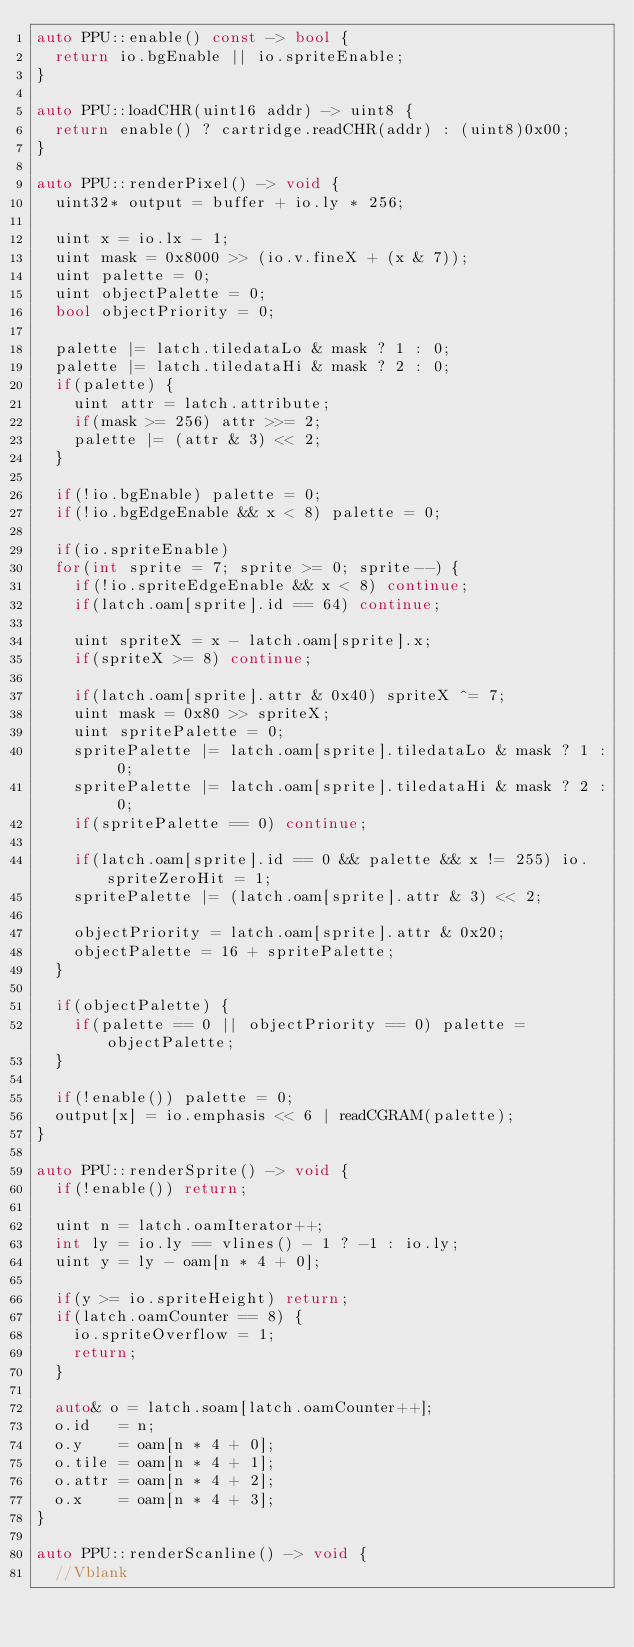Convert code to text. <code><loc_0><loc_0><loc_500><loc_500><_C++_>auto PPU::enable() const -> bool {
  return io.bgEnable || io.spriteEnable;
}

auto PPU::loadCHR(uint16 addr) -> uint8 {
  return enable() ? cartridge.readCHR(addr) : (uint8)0x00;
}

auto PPU::renderPixel() -> void {
  uint32* output = buffer + io.ly * 256;

  uint x = io.lx - 1;
  uint mask = 0x8000 >> (io.v.fineX + (x & 7));
  uint palette = 0;
  uint objectPalette = 0;
  bool objectPriority = 0;

  palette |= latch.tiledataLo & mask ? 1 : 0;
  palette |= latch.tiledataHi & mask ? 2 : 0;
  if(palette) {
    uint attr = latch.attribute;
    if(mask >= 256) attr >>= 2;
    palette |= (attr & 3) << 2;
  }

  if(!io.bgEnable) palette = 0;
  if(!io.bgEdgeEnable && x < 8) palette = 0;

  if(io.spriteEnable)
  for(int sprite = 7; sprite >= 0; sprite--) {
    if(!io.spriteEdgeEnable && x < 8) continue;
    if(latch.oam[sprite].id == 64) continue;

    uint spriteX = x - latch.oam[sprite].x;
    if(spriteX >= 8) continue;

    if(latch.oam[sprite].attr & 0x40) spriteX ^= 7;
    uint mask = 0x80 >> spriteX;
    uint spritePalette = 0;
    spritePalette |= latch.oam[sprite].tiledataLo & mask ? 1 : 0;
    spritePalette |= latch.oam[sprite].tiledataHi & mask ? 2 : 0;
    if(spritePalette == 0) continue;

    if(latch.oam[sprite].id == 0 && palette && x != 255) io.spriteZeroHit = 1;
    spritePalette |= (latch.oam[sprite].attr & 3) << 2;

    objectPriority = latch.oam[sprite].attr & 0x20;
    objectPalette = 16 + spritePalette;
  }

  if(objectPalette) {
    if(palette == 0 || objectPriority == 0) palette = objectPalette;
  }

  if(!enable()) palette = 0;
  output[x] = io.emphasis << 6 | readCGRAM(palette);
}

auto PPU::renderSprite() -> void {
  if(!enable()) return;

  uint n = latch.oamIterator++;
  int ly = io.ly == vlines() - 1 ? -1 : io.ly;
  uint y = ly - oam[n * 4 + 0];

  if(y >= io.spriteHeight) return;
  if(latch.oamCounter == 8) {
    io.spriteOverflow = 1;
    return;
  }

  auto& o = latch.soam[latch.oamCounter++];
  o.id   = n;
  o.y    = oam[n * 4 + 0];
  o.tile = oam[n * 4 + 1];
  o.attr = oam[n * 4 + 2];
  o.x    = oam[n * 4 + 3];
}

auto PPU::renderScanline() -> void {
  //Vblank</code> 